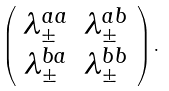Convert formula to latex. <formula><loc_0><loc_0><loc_500><loc_500>\left ( \begin{array} { c c } \lambda ^ { a a } _ { \pm } & \lambda ^ { a b } _ { \pm } \\ \lambda ^ { b a } _ { \pm } & \lambda ^ { b b } _ { \pm } \end{array} \right ) .</formula> 